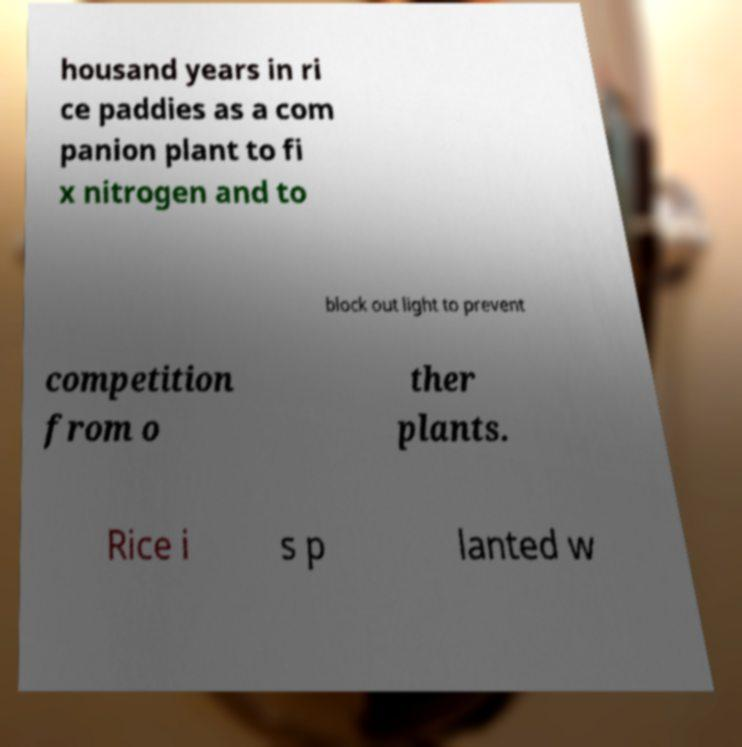For documentation purposes, I need the text within this image transcribed. Could you provide that? housand years in ri ce paddies as a com panion plant to fi x nitrogen and to block out light to prevent competition from o ther plants. Rice i s p lanted w 